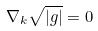<formula> <loc_0><loc_0><loc_500><loc_500>\nabla _ { k } \sqrt { | g | } = 0</formula> 